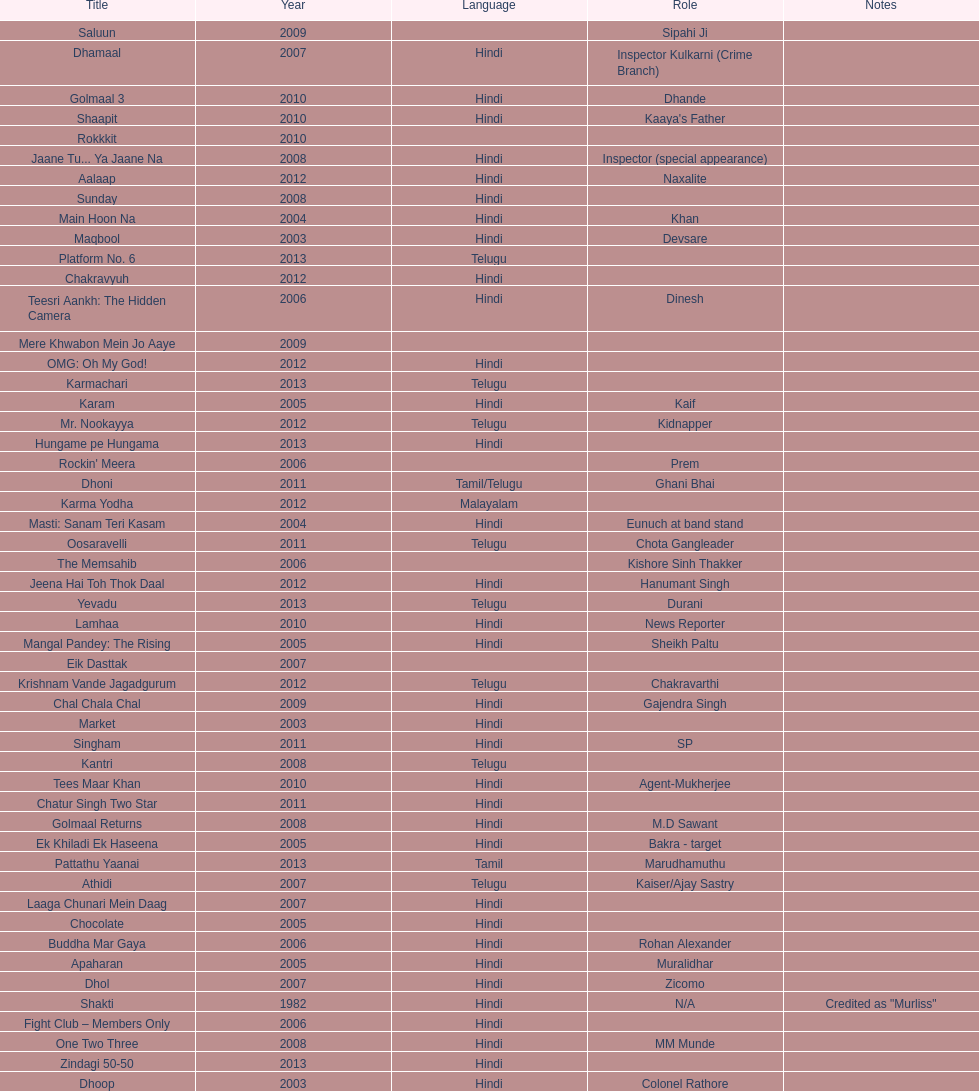What is the first language after hindi Telugu. 